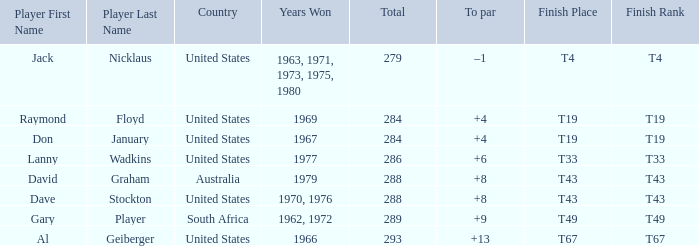What is the average total in 1969? 284.0. 